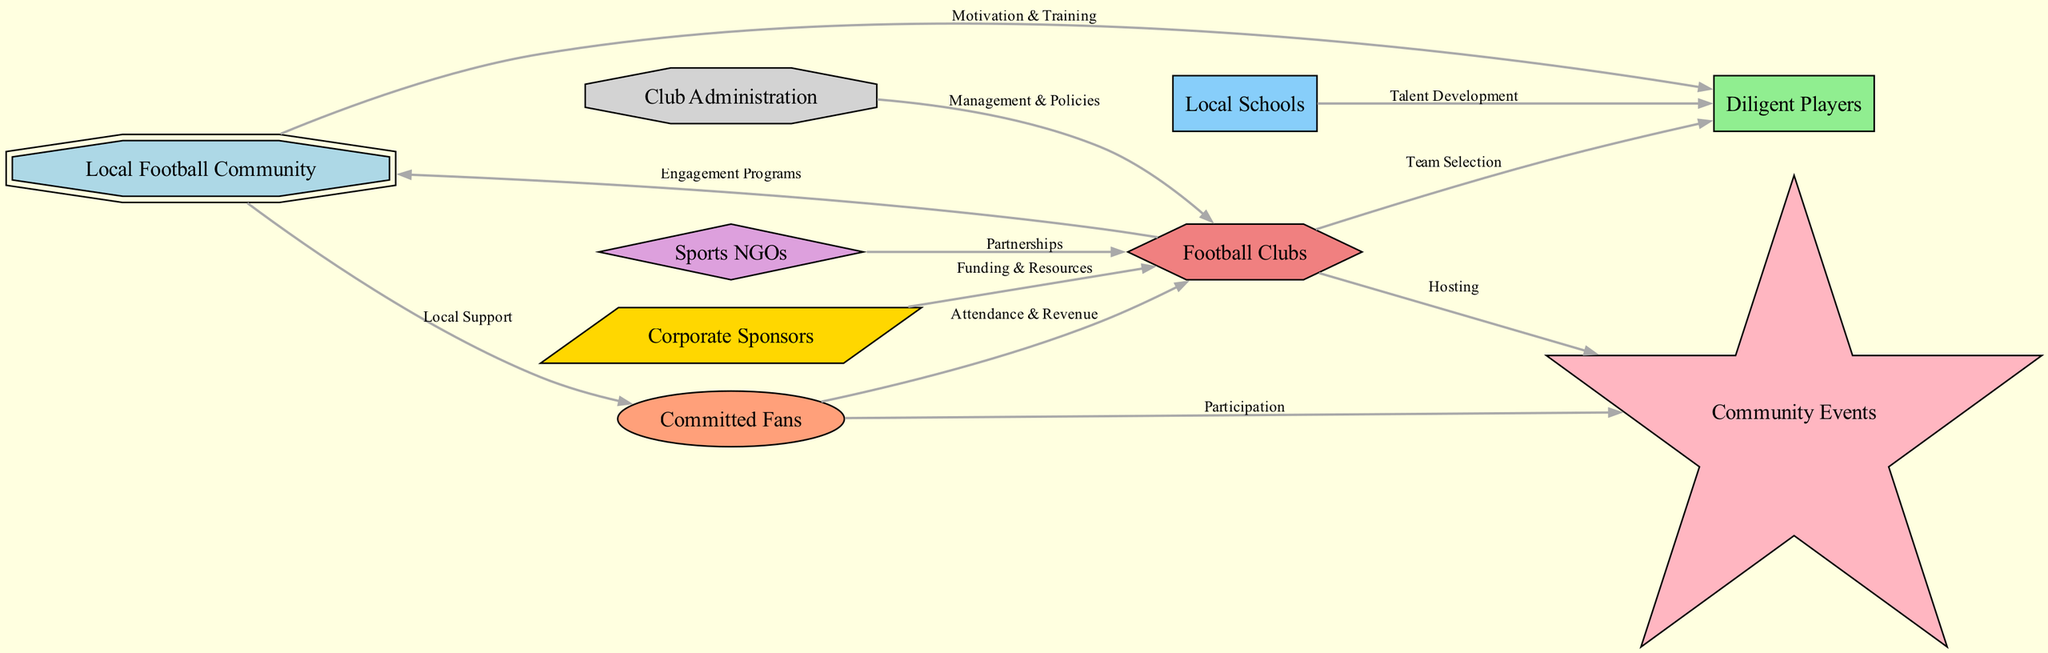What is the total number of nodes in the diagram? The total number of nodes can be counted by examining the node list provided in the diagram data. There are 9 nodes listed in total: Local Football Community, Diligent Players, Committed Fans, Football Clubs, Local Schools, Sports NGOs, Corporate Sponsors, Club Administration, and Community Events.
Answer: 9 Which node is connected to both players and clubs? By analyzing the edges (connections) in the diagram, I can see that the node "clubs" has edges leading from both "players" (Team Selection) and "fans" (Attendance & Revenue). In this case, the node of interest from the two connections is "clubs".
Answer: clubs What type of relationship exists between fans and events? The relationship between the nodes "fans" and "events" is specified by the edge labeled "Participation". This indicates that fans are involved in community events through participation.
Answer: Participation How many edges connect the local football community to other nodes? To determine this, I will count the edges originating from the "community" node in the edges list. There are 2 edges from the "community" node: one connects to "players" (Motivation & Training) and the other to "fans" (Local Support).
Answer: 2 What role do NGOs have in the network? NGOs are connected to clubs through a labeled edge named "Partnerships". This indicates that Sports NGOs collaborate with clubs, playing a supportive role through partnership initiatives.
Answer: Partnerships Which node has the most outgoing connections? By examining the clubs node, it has outgoing connections to "community" (Engagement Programs), "events" (Hosting), and "players" (Team Selection) totaling 3 outgoing edges. Other nodes have fewer connections.
Answer: clubs What is the primary source of funding for the clubs? According to the edges defined in the diagram, the connection from "sponsors" to "clubs" is labeled as "Funding & Resources". This directly indicates that sponsors are a primary funding source for clubs.
Answer: Funding & Resources What is indicated by the edge between schools and players? The edge from "schools" to "players" is labeled "Talent Development", suggesting that local schools play a crucial role in developing talent among players.
Answer: Talent Development Which node represents the administration aspect of clubs? The node labeled "administration" represents the management and policy-making aspects that govern the operations of football clubs.
Answer: Club Administration 